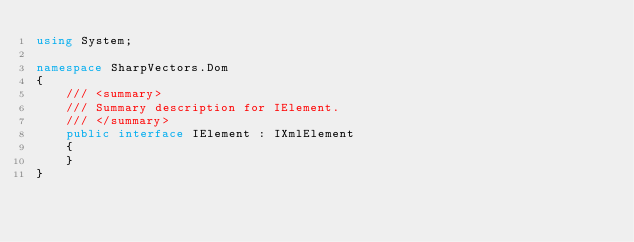Convert code to text. <code><loc_0><loc_0><loc_500><loc_500><_C#_>using System;

namespace SharpVectors.Dom
{
	/// <summary>
	/// Summary description for IElement.
	/// </summary>
	public interface IElement : IXmlElement      
	{
	}
}
</code> 